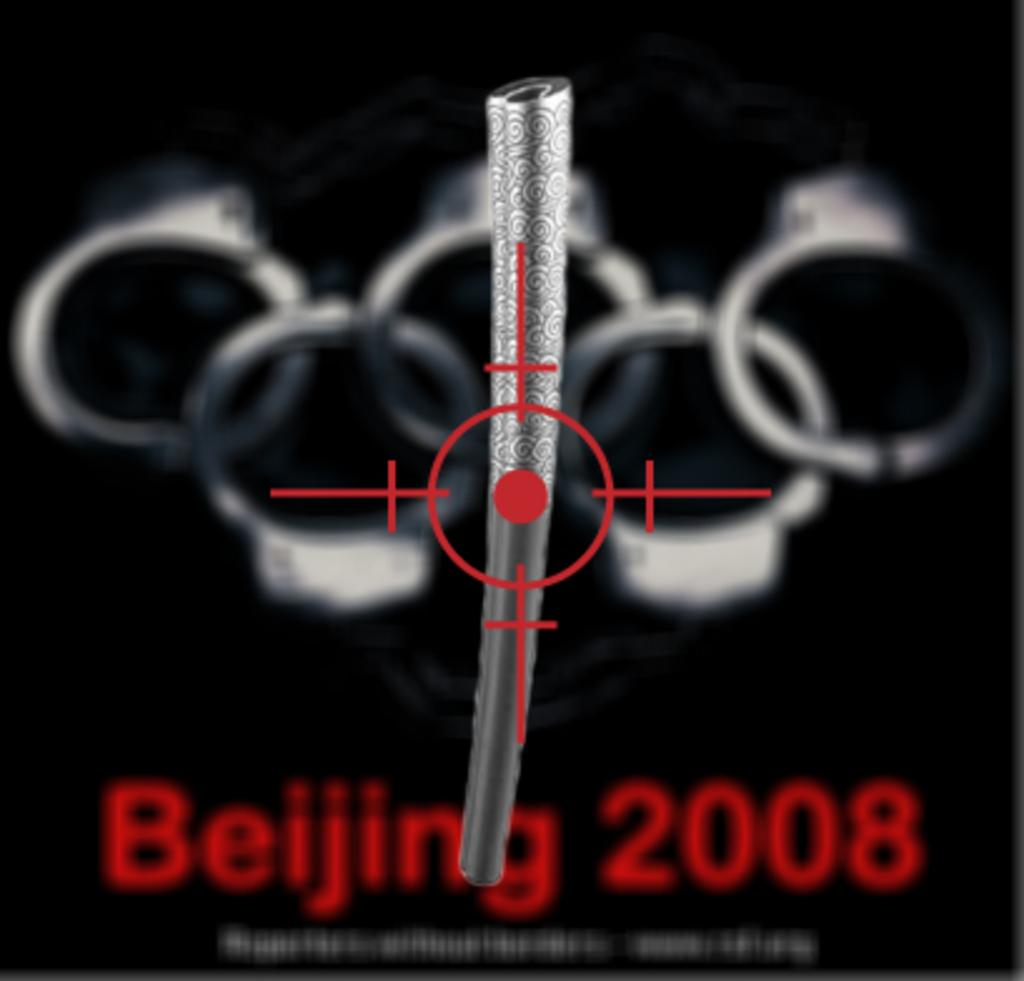<image>
Write a terse but informative summary of the picture. A sign that is promoting the Beijing 2008 event. 